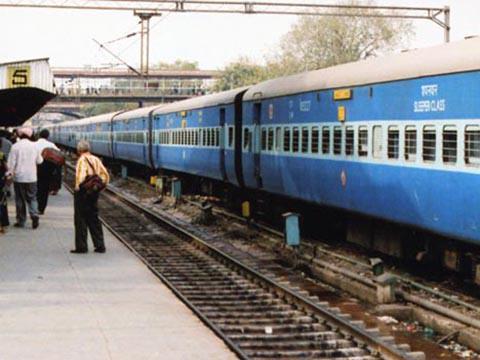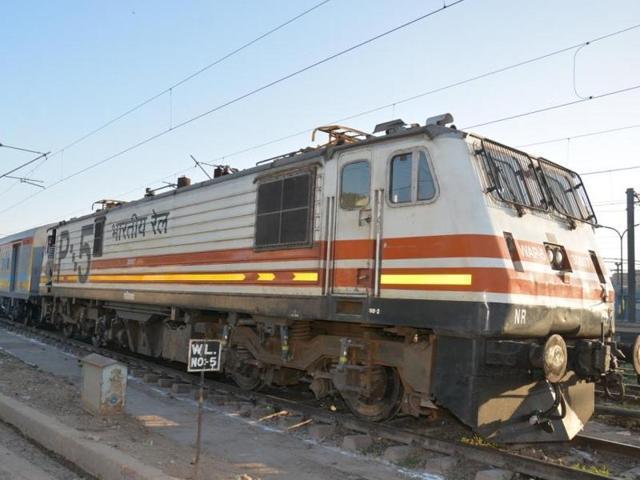The first image is the image on the left, the second image is the image on the right. For the images displayed, is the sentence "Multiple people stand to one side of a train in one image, but no one is by the train in the other image, which angles rightward." factually correct? Answer yes or no. Yes. The first image is the image on the left, the second image is the image on the right. For the images shown, is this caption "Several people are standing on the platform near the train in the image on the left." true? Answer yes or no. Yes. 